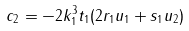Convert formula to latex. <formula><loc_0><loc_0><loc_500><loc_500>c _ { 2 } = - 2 k _ { 1 } ^ { 3 } t _ { 1 } ( 2 r _ { 1 } u _ { 1 } + s _ { 1 } u _ { 2 } )</formula> 